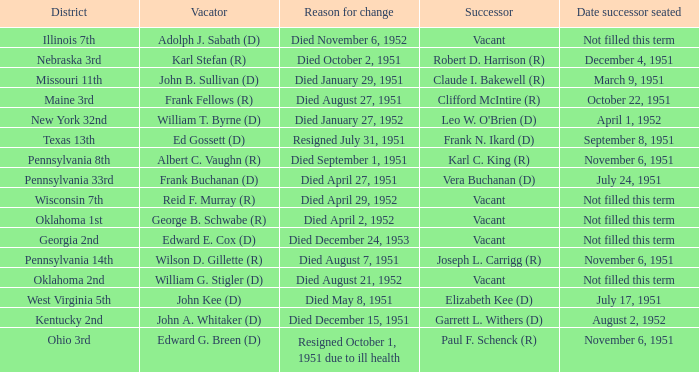Who was the successor for the Kentucky 2nd district? Garrett L. Withers (D). 